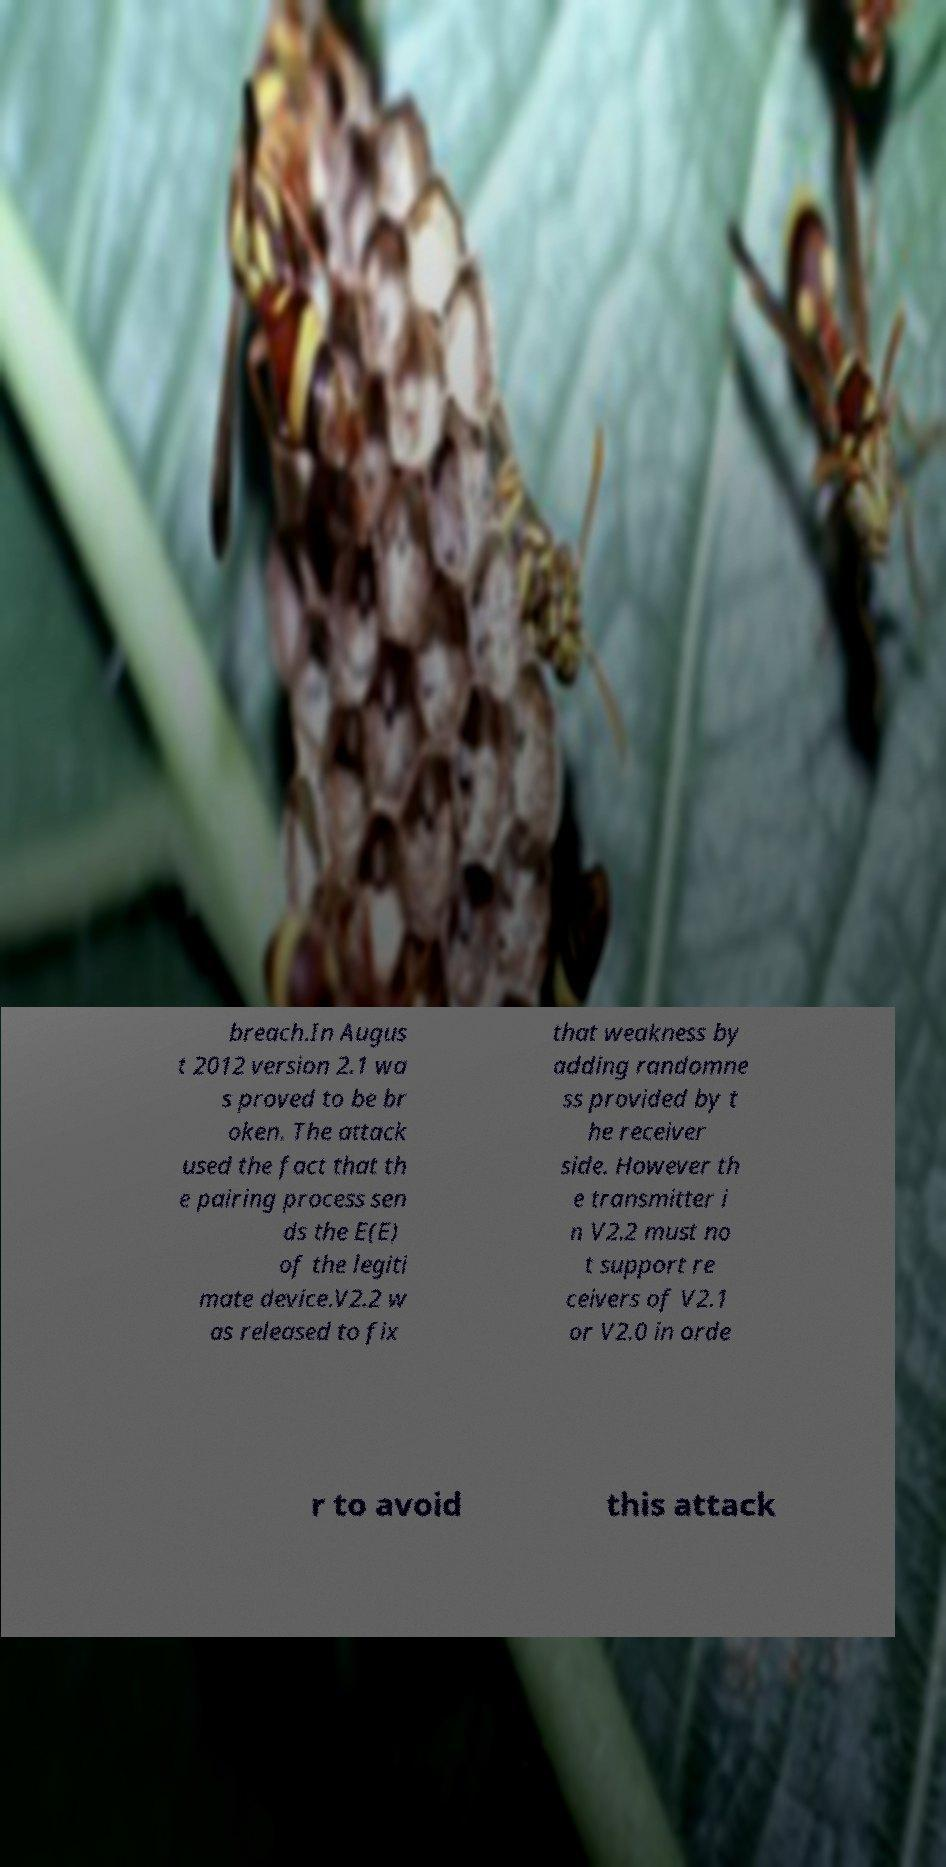Please read and relay the text visible in this image. What does it say? breach.In Augus t 2012 version 2.1 wa s proved to be br oken. The attack used the fact that th e pairing process sen ds the E(E) of the legiti mate device.V2.2 w as released to fix that weakness by adding randomne ss provided by t he receiver side. However th e transmitter i n V2.2 must no t support re ceivers of V2.1 or V2.0 in orde r to avoid this attack 